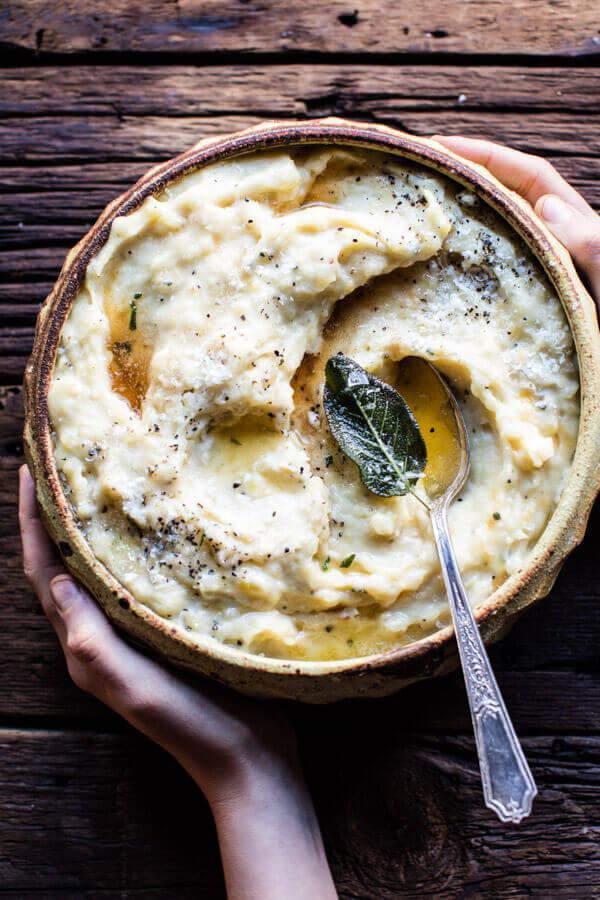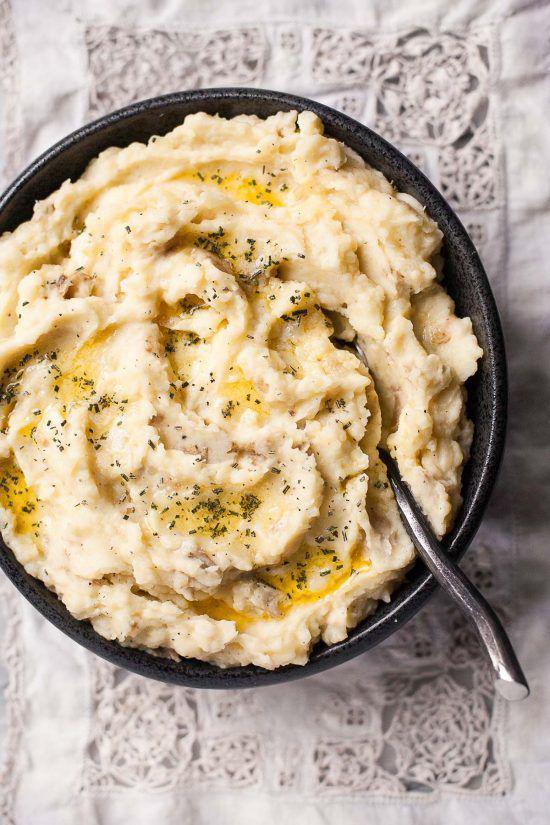The first image is the image on the left, the second image is the image on the right. For the images displayed, is the sentence "Each image shows a spoon with a bowl of mashed potatoes, and the spoons are made of the same type of material." factually correct? Answer yes or no. Yes. The first image is the image on the left, the second image is the image on the right. Assess this claim about the two images: "The dish in the image on the left has a spoon in it.". Correct or not? Answer yes or no. Yes. 